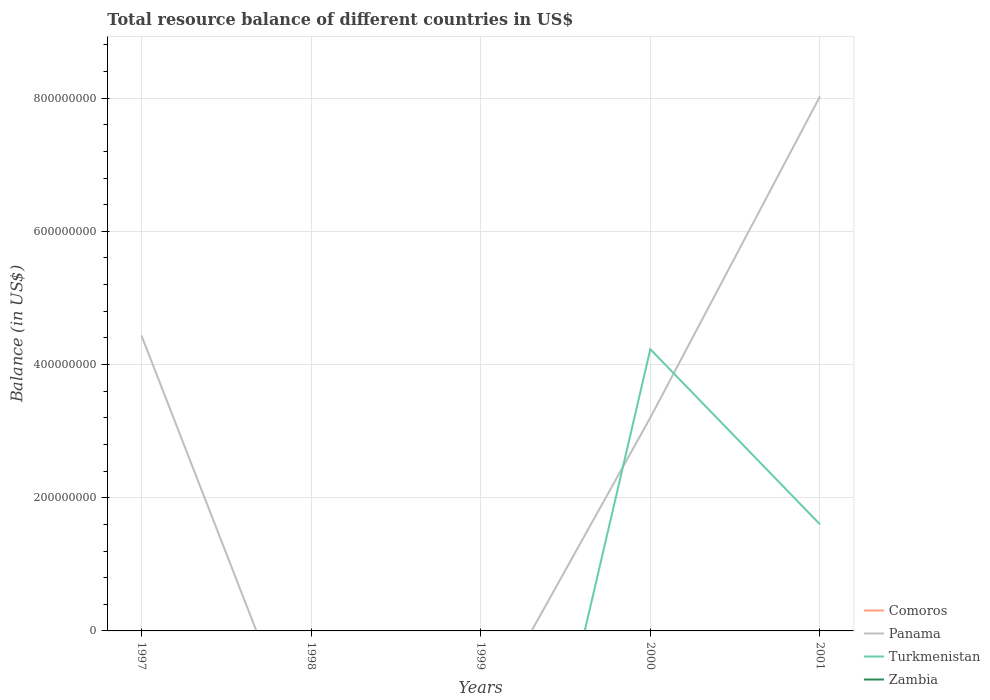What is the total total resource balance in Panama in the graph?
Provide a short and direct response. -4.82e+08. What is the difference between the highest and the second highest total resource balance in Turkmenistan?
Offer a terse response. 4.23e+08. How many lines are there?
Offer a terse response. 2. How many years are there in the graph?
Provide a short and direct response. 5. What is the difference between two consecutive major ticks on the Y-axis?
Your answer should be very brief. 2.00e+08. Does the graph contain grids?
Make the answer very short. Yes. Where does the legend appear in the graph?
Ensure brevity in your answer.  Bottom right. What is the title of the graph?
Offer a terse response. Total resource balance of different countries in US$. Does "Algeria" appear as one of the legend labels in the graph?
Your response must be concise. No. What is the label or title of the X-axis?
Give a very brief answer. Years. What is the label or title of the Y-axis?
Give a very brief answer. Balance (in US$). What is the Balance (in US$) in Comoros in 1997?
Your answer should be compact. 0. What is the Balance (in US$) in Panama in 1997?
Your response must be concise. 4.44e+08. What is the Balance (in US$) of Turkmenistan in 1997?
Your response must be concise. 0. What is the Balance (in US$) in Comoros in 1998?
Provide a short and direct response. 0. What is the Balance (in US$) of Panama in 1998?
Offer a terse response. 0. What is the Balance (in US$) of Turkmenistan in 1998?
Provide a short and direct response. 0. What is the Balance (in US$) in Comoros in 1999?
Provide a succinct answer. 0. What is the Balance (in US$) in Turkmenistan in 1999?
Give a very brief answer. 0. What is the Balance (in US$) in Comoros in 2000?
Give a very brief answer. 0. What is the Balance (in US$) in Panama in 2000?
Make the answer very short. 3.20e+08. What is the Balance (in US$) in Turkmenistan in 2000?
Your answer should be very brief. 4.23e+08. What is the Balance (in US$) of Zambia in 2000?
Offer a terse response. 0. What is the Balance (in US$) of Panama in 2001?
Keep it short and to the point. 8.03e+08. What is the Balance (in US$) in Turkmenistan in 2001?
Your answer should be very brief. 1.60e+08. What is the Balance (in US$) of Zambia in 2001?
Provide a short and direct response. 0. Across all years, what is the maximum Balance (in US$) in Panama?
Offer a terse response. 8.03e+08. Across all years, what is the maximum Balance (in US$) in Turkmenistan?
Your response must be concise. 4.23e+08. Across all years, what is the minimum Balance (in US$) of Panama?
Ensure brevity in your answer.  0. What is the total Balance (in US$) in Comoros in the graph?
Ensure brevity in your answer.  0. What is the total Balance (in US$) of Panama in the graph?
Ensure brevity in your answer.  1.57e+09. What is the total Balance (in US$) of Turkmenistan in the graph?
Ensure brevity in your answer.  5.83e+08. What is the total Balance (in US$) of Zambia in the graph?
Provide a short and direct response. 0. What is the difference between the Balance (in US$) in Panama in 1997 and that in 2000?
Offer a terse response. 1.23e+08. What is the difference between the Balance (in US$) of Panama in 1997 and that in 2001?
Give a very brief answer. -3.59e+08. What is the difference between the Balance (in US$) of Panama in 2000 and that in 2001?
Give a very brief answer. -4.82e+08. What is the difference between the Balance (in US$) in Turkmenistan in 2000 and that in 2001?
Your response must be concise. 2.63e+08. What is the difference between the Balance (in US$) in Panama in 1997 and the Balance (in US$) in Turkmenistan in 2000?
Make the answer very short. 2.07e+07. What is the difference between the Balance (in US$) of Panama in 1997 and the Balance (in US$) of Turkmenistan in 2001?
Provide a succinct answer. 2.84e+08. What is the difference between the Balance (in US$) in Panama in 2000 and the Balance (in US$) in Turkmenistan in 2001?
Make the answer very short. 1.60e+08. What is the average Balance (in US$) in Comoros per year?
Ensure brevity in your answer.  0. What is the average Balance (in US$) in Panama per year?
Provide a succinct answer. 3.13e+08. What is the average Balance (in US$) in Turkmenistan per year?
Your answer should be compact. 1.17e+08. In the year 2000, what is the difference between the Balance (in US$) of Panama and Balance (in US$) of Turkmenistan?
Provide a succinct answer. -1.03e+08. In the year 2001, what is the difference between the Balance (in US$) of Panama and Balance (in US$) of Turkmenistan?
Keep it short and to the point. 6.43e+08. What is the ratio of the Balance (in US$) of Panama in 1997 to that in 2000?
Offer a terse response. 1.39. What is the ratio of the Balance (in US$) in Panama in 1997 to that in 2001?
Offer a terse response. 0.55. What is the ratio of the Balance (in US$) of Panama in 2000 to that in 2001?
Your answer should be compact. 0.4. What is the ratio of the Balance (in US$) of Turkmenistan in 2000 to that in 2001?
Make the answer very short. 2.64. What is the difference between the highest and the second highest Balance (in US$) of Panama?
Your answer should be compact. 3.59e+08. What is the difference between the highest and the lowest Balance (in US$) in Panama?
Your answer should be compact. 8.03e+08. What is the difference between the highest and the lowest Balance (in US$) in Turkmenistan?
Make the answer very short. 4.23e+08. 